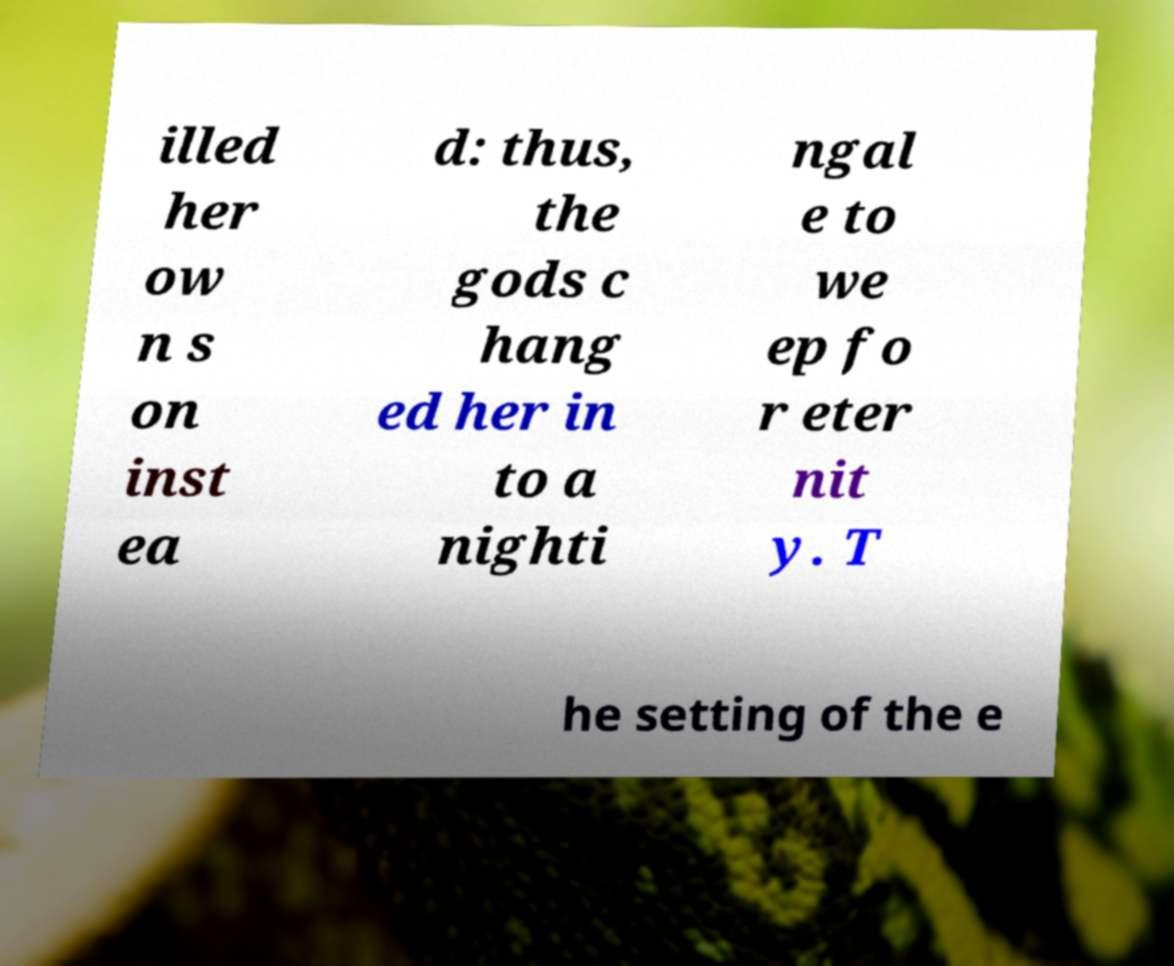Please read and relay the text visible in this image. What does it say? illed her ow n s on inst ea d: thus, the gods c hang ed her in to a nighti ngal e to we ep fo r eter nit y. T he setting of the e 